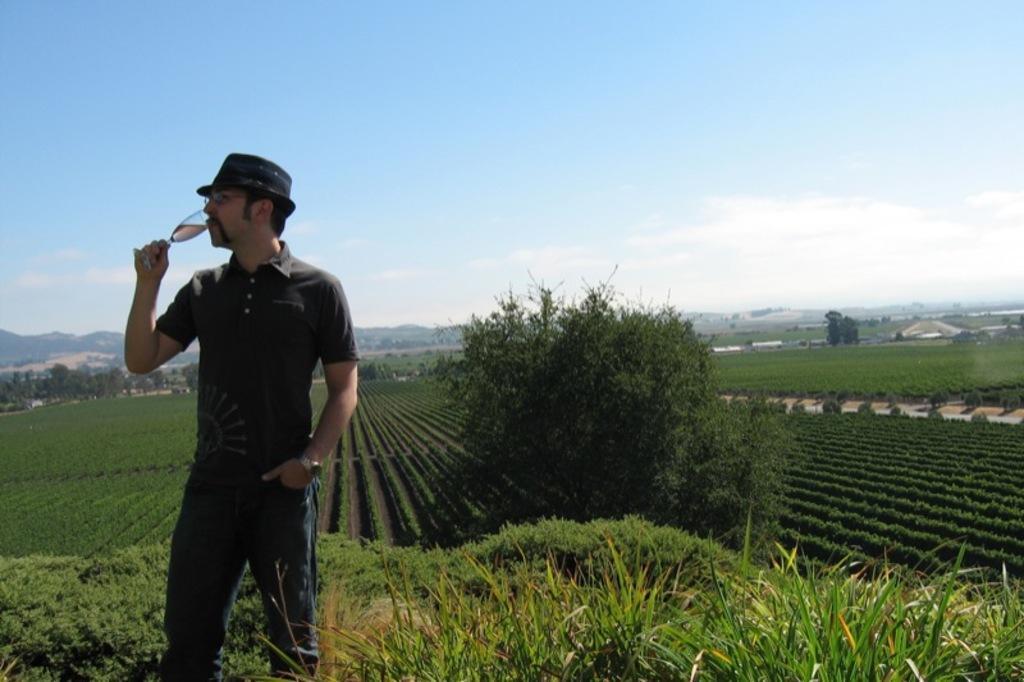In one or two sentences, can you explain what this image depicts? In this picture I can see a man in front who is standing and holding a glass near to his mouth and I see that he is wearing a hat and I can see the plants near him. In the middle of this picture I can see number of plants and few trees. In the background I can see the sky. 